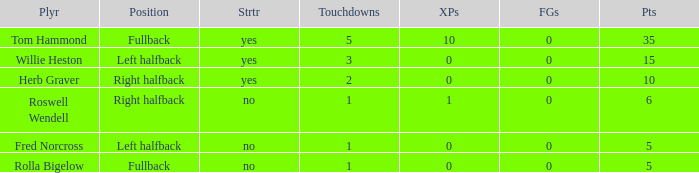What is the lowest number of field goals for a player with 3 touchdowns? 0.0. 